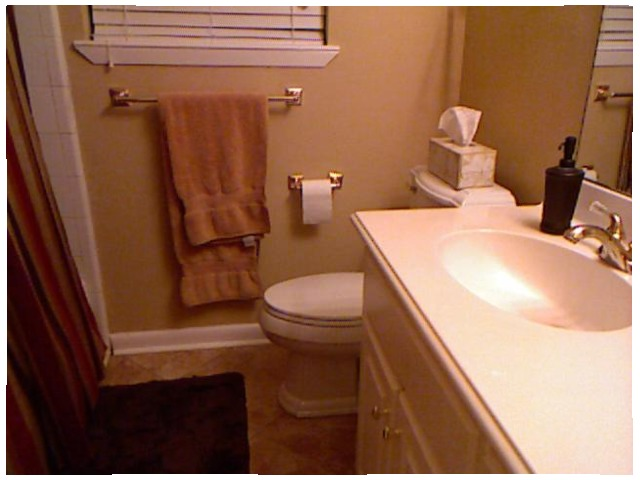<image>
Is the sink to the left of the toilet? No. The sink is not to the left of the toilet. From this viewpoint, they have a different horizontal relationship. 